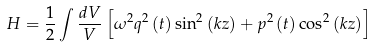Convert formula to latex. <formula><loc_0><loc_0><loc_500><loc_500>H = \frac { 1 } { 2 } \int \frac { d V } { V } \left [ \omega ^ { 2 } q ^ { 2 } \left ( t \right ) \sin ^ { 2 } \left ( k z \right ) + p ^ { 2 } \left ( t \right ) \cos ^ { 2 } \left ( k z \right ) \right ]</formula> 